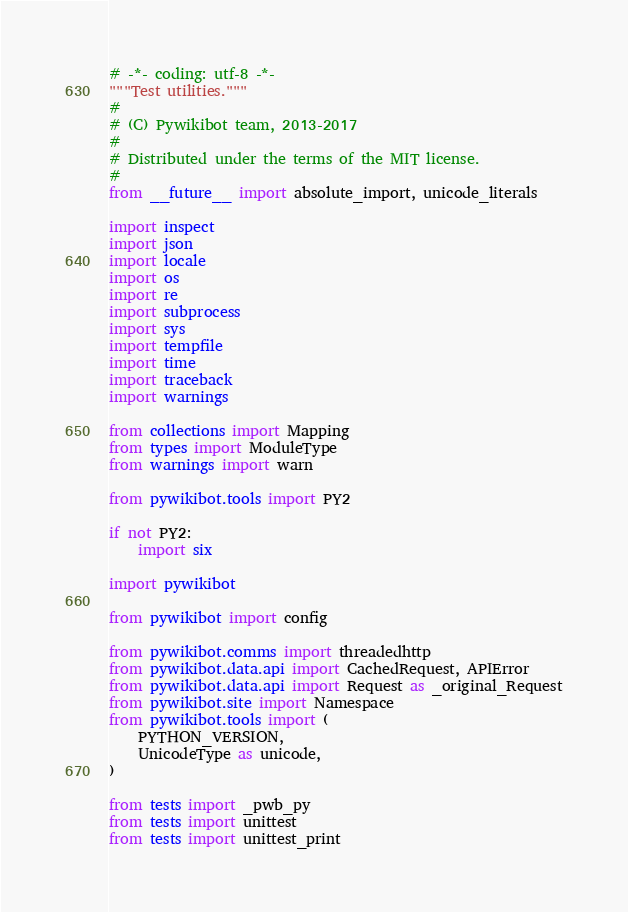Convert code to text. <code><loc_0><loc_0><loc_500><loc_500><_Python_># -*- coding: utf-8 -*-
"""Test utilities."""
#
# (C) Pywikibot team, 2013-2017
#
# Distributed under the terms of the MIT license.
#
from __future__ import absolute_import, unicode_literals

import inspect
import json
import locale
import os
import re
import subprocess
import sys
import tempfile
import time
import traceback
import warnings

from collections import Mapping
from types import ModuleType
from warnings import warn

from pywikibot.tools import PY2

if not PY2:
    import six

import pywikibot

from pywikibot import config

from pywikibot.comms import threadedhttp
from pywikibot.data.api import CachedRequest, APIError
from pywikibot.data.api import Request as _original_Request
from pywikibot.site import Namespace
from pywikibot.tools import (
    PYTHON_VERSION,
    UnicodeType as unicode,
)

from tests import _pwb_py
from tests import unittest
from tests import unittest_print
</code> 